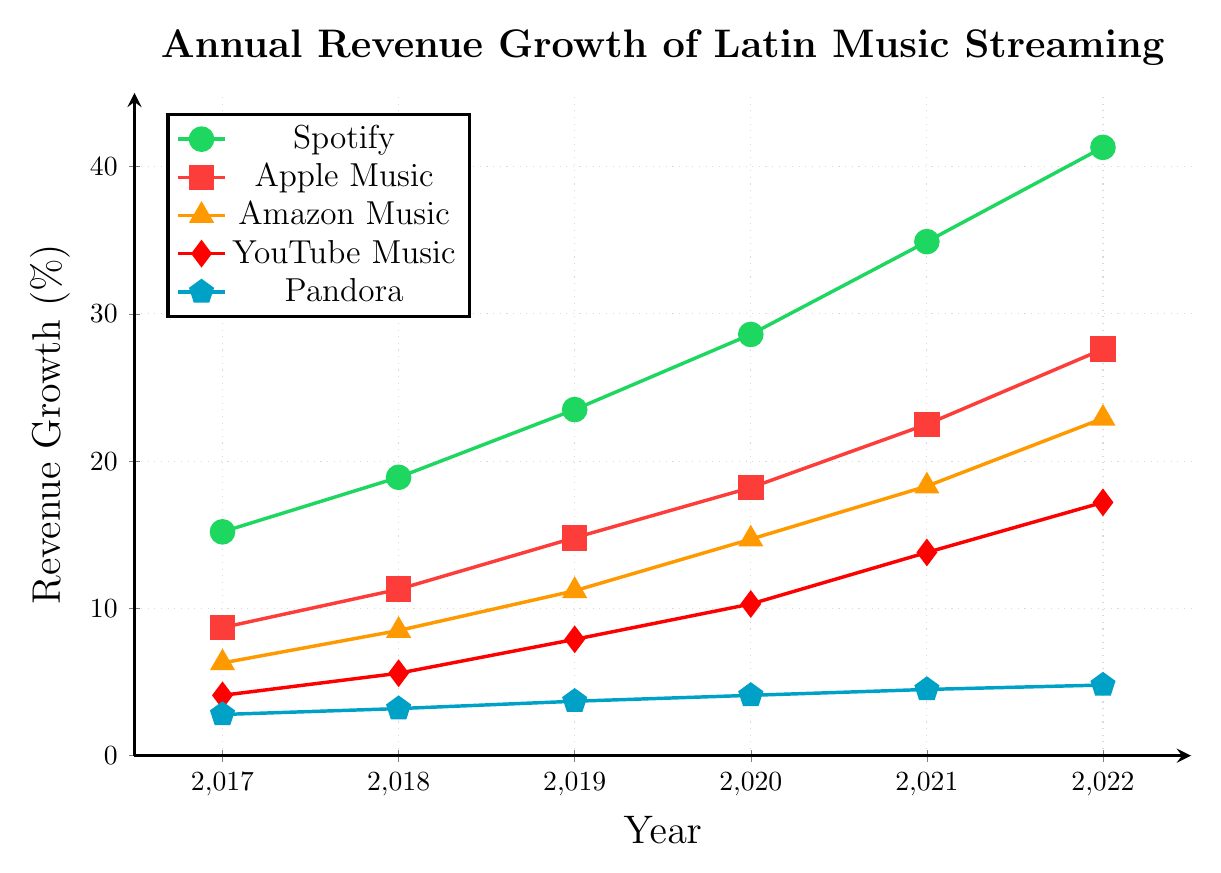What is the annual revenue growth of Spotify in 2019? Check the coordinates for Spotify in the year 2019, which are indicated on the figure with a green line and a circular marker. The value is shown next to 2019 on the x-axis.
Answer: 23.5% How much did Amazon Music's revenue grow from 2018 to 2019? Find the coordinates for Amazon Music in 2018 and 2019, represented by the orange line with a triangle marker. Subtract the 2018 value from the 2019 value: 11.2 - 8.5.
Answer: 2.7% Which platform had the least revenue growth in 2022? Observe the data points for each platform in 2022. Pandora, represented by the blue line with a pentagon marker, has the lowest data point on the y-axis in 2022.
Answer: Pandora Compare the revenue growth of Apple Music and YouTube Music in 2020. Which platform had higher growth? Identify the data points for Apple Music and YouTube Music in 2020, represented by red and dark red lines, respectively. Compare their y-axis values.
Answer: Apple Music In which year did Spotify surpass a 30% annual revenue growth? Look at the green line for Spotify and find the first year where the y-axis value exceeds 30. This occurs in the year 2021.
Answer: 2021 Calculate the average annual revenue growth for Pandora from 2017 to 2022. Sum the annual revenue growth values for Pandora from 2017 to 2022 and then divide by the number of years (6). The values are 2.8, 3.2, 3.7, 4.1, 4.5, and 4.8. The sum is 23.1, so the average is 23.1/6.
Answer: 3.85% How does the revenue growth of YouTube Music in 2021 compare to its growth in 2019? Identify the data points for YouTube Music in 2021 and 2019 from the dark red line with diamond marker. Compare the y-axis values: 13.8 for 2021 and 7.9 for 2019.
Answer: 5.9% higher in 2021 What was the difference in annual revenue growth between Spotify and Amazon Music in 2018? Check the data points for both Spotify and Amazon Music in 2018; Spotify is 18.9 and Amazon Music is 8.5. Subtract Amazon Music's value from Spotify's: 18.9 - 8.5.
Answer: 10.4% By how much did the annual revenue growth of Apple Music increase from 2019 to 2022? Identify the data points for Apple Music in 2019 and 2022 from the red line with square marker. Subtract the 2019 value from the 2022 value: 27.6 - 14.8.
Answer: 12.8% Which platform had the most significant increase in revenue growth from 2017 to 2022? Compare the values for each platform in 2017 versus 2022. Spotify has the largest increase from 15.2 in 2017 to 41.3 in 2022.
Answer: Spotify 